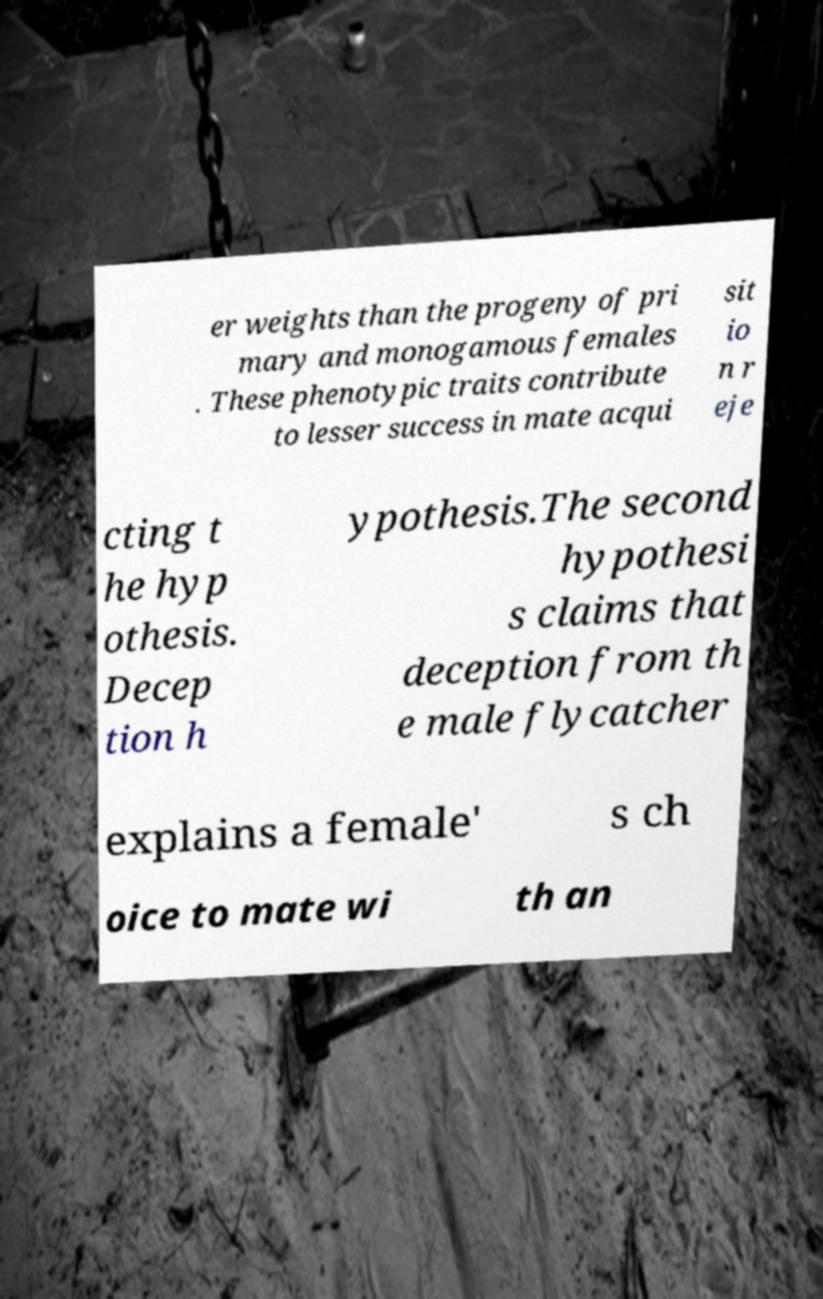Can you read and provide the text displayed in the image?This photo seems to have some interesting text. Can you extract and type it out for me? er weights than the progeny of pri mary and monogamous females . These phenotypic traits contribute to lesser success in mate acqui sit io n r eje cting t he hyp othesis. Decep tion h ypothesis.The second hypothesi s claims that deception from th e male flycatcher explains a female' s ch oice to mate wi th an 